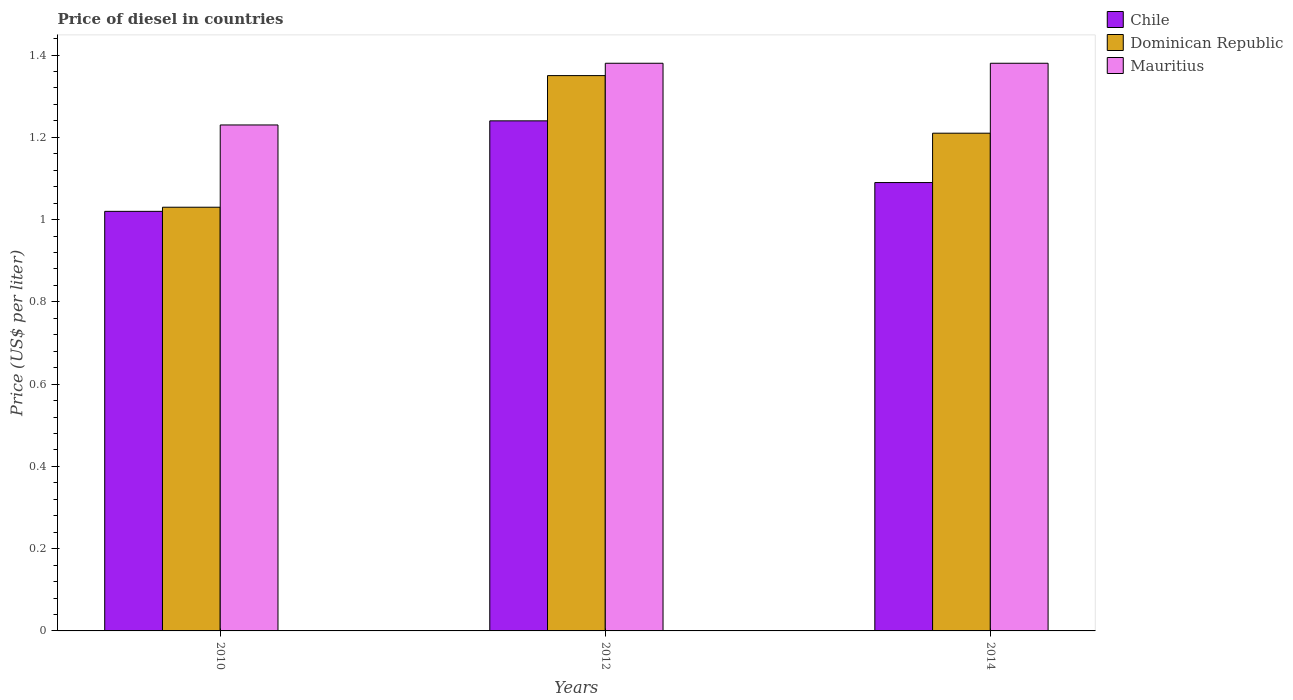How many different coloured bars are there?
Provide a short and direct response. 3. How many bars are there on the 3rd tick from the left?
Offer a terse response. 3. How many bars are there on the 3rd tick from the right?
Provide a succinct answer. 3. What is the label of the 3rd group of bars from the left?
Provide a succinct answer. 2014. What is the price of diesel in Chile in 2012?
Your response must be concise. 1.24. Across all years, what is the maximum price of diesel in Chile?
Keep it short and to the point. 1.24. Across all years, what is the minimum price of diesel in Mauritius?
Keep it short and to the point. 1.23. In which year was the price of diesel in Dominican Republic minimum?
Offer a terse response. 2010. What is the total price of diesel in Mauritius in the graph?
Give a very brief answer. 3.99. What is the difference between the price of diesel in Dominican Republic in 2010 and that in 2012?
Ensure brevity in your answer.  -0.32. What is the difference between the price of diesel in Chile in 2010 and the price of diesel in Dominican Republic in 2014?
Your answer should be very brief. -0.19. What is the average price of diesel in Mauritius per year?
Offer a terse response. 1.33. In the year 2010, what is the difference between the price of diesel in Mauritius and price of diesel in Dominican Republic?
Your answer should be very brief. 0.2. In how many years, is the price of diesel in Mauritius greater than 1.4000000000000001 US$?
Your answer should be very brief. 0. What is the ratio of the price of diesel in Mauritius in 2010 to that in 2012?
Give a very brief answer. 0.89. Is the price of diesel in Chile in 2012 less than that in 2014?
Your response must be concise. No. What is the difference between the highest and the second highest price of diesel in Dominican Republic?
Give a very brief answer. 0.14. What is the difference between the highest and the lowest price of diesel in Chile?
Give a very brief answer. 0.22. In how many years, is the price of diesel in Dominican Republic greater than the average price of diesel in Dominican Republic taken over all years?
Keep it short and to the point. 2. Is the sum of the price of diesel in Chile in 2012 and 2014 greater than the maximum price of diesel in Mauritius across all years?
Make the answer very short. Yes. What does the 3rd bar from the left in 2014 represents?
Provide a succinct answer. Mauritius. What does the 2nd bar from the right in 2012 represents?
Give a very brief answer. Dominican Republic. How many bars are there?
Keep it short and to the point. 9. Are all the bars in the graph horizontal?
Your answer should be very brief. No. Are the values on the major ticks of Y-axis written in scientific E-notation?
Offer a terse response. No. Does the graph contain any zero values?
Your answer should be compact. No. Does the graph contain grids?
Offer a very short reply. No. What is the title of the graph?
Your response must be concise. Price of diesel in countries. What is the label or title of the Y-axis?
Provide a short and direct response. Price (US$ per liter). What is the Price (US$ per liter) of Chile in 2010?
Make the answer very short. 1.02. What is the Price (US$ per liter) of Dominican Republic in 2010?
Keep it short and to the point. 1.03. What is the Price (US$ per liter) in Mauritius in 2010?
Provide a succinct answer. 1.23. What is the Price (US$ per liter) in Chile in 2012?
Your answer should be very brief. 1.24. What is the Price (US$ per liter) in Dominican Republic in 2012?
Provide a short and direct response. 1.35. What is the Price (US$ per liter) in Mauritius in 2012?
Your response must be concise. 1.38. What is the Price (US$ per liter) in Chile in 2014?
Offer a very short reply. 1.09. What is the Price (US$ per liter) in Dominican Republic in 2014?
Provide a short and direct response. 1.21. What is the Price (US$ per liter) of Mauritius in 2014?
Your answer should be very brief. 1.38. Across all years, what is the maximum Price (US$ per liter) of Chile?
Your answer should be compact. 1.24. Across all years, what is the maximum Price (US$ per liter) in Dominican Republic?
Ensure brevity in your answer.  1.35. Across all years, what is the maximum Price (US$ per liter) in Mauritius?
Provide a short and direct response. 1.38. Across all years, what is the minimum Price (US$ per liter) in Dominican Republic?
Make the answer very short. 1.03. Across all years, what is the minimum Price (US$ per liter) in Mauritius?
Ensure brevity in your answer.  1.23. What is the total Price (US$ per liter) in Chile in the graph?
Offer a terse response. 3.35. What is the total Price (US$ per liter) of Dominican Republic in the graph?
Provide a short and direct response. 3.59. What is the total Price (US$ per liter) in Mauritius in the graph?
Provide a short and direct response. 3.99. What is the difference between the Price (US$ per liter) of Chile in 2010 and that in 2012?
Keep it short and to the point. -0.22. What is the difference between the Price (US$ per liter) in Dominican Republic in 2010 and that in 2012?
Provide a short and direct response. -0.32. What is the difference between the Price (US$ per liter) in Chile in 2010 and that in 2014?
Provide a short and direct response. -0.07. What is the difference between the Price (US$ per liter) in Dominican Republic in 2010 and that in 2014?
Your response must be concise. -0.18. What is the difference between the Price (US$ per liter) of Dominican Republic in 2012 and that in 2014?
Keep it short and to the point. 0.14. What is the difference between the Price (US$ per liter) of Mauritius in 2012 and that in 2014?
Keep it short and to the point. 0. What is the difference between the Price (US$ per liter) in Chile in 2010 and the Price (US$ per liter) in Dominican Republic in 2012?
Make the answer very short. -0.33. What is the difference between the Price (US$ per liter) in Chile in 2010 and the Price (US$ per liter) in Mauritius in 2012?
Make the answer very short. -0.36. What is the difference between the Price (US$ per liter) in Dominican Republic in 2010 and the Price (US$ per liter) in Mauritius in 2012?
Provide a short and direct response. -0.35. What is the difference between the Price (US$ per liter) of Chile in 2010 and the Price (US$ per liter) of Dominican Republic in 2014?
Your response must be concise. -0.19. What is the difference between the Price (US$ per liter) of Chile in 2010 and the Price (US$ per liter) of Mauritius in 2014?
Your response must be concise. -0.36. What is the difference between the Price (US$ per liter) in Dominican Republic in 2010 and the Price (US$ per liter) in Mauritius in 2014?
Provide a succinct answer. -0.35. What is the difference between the Price (US$ per liter) of Chile in 2012 and the Price (US$ per liter) of Dominican Republic in 2014?
Provide a succinct answer. 0.03. What is the difference between the Price (US$ per liter) in Chile in 2012 and the Price (US$ per liter) in Mauritius in 2014?
Ensure brevity in your answer.  -0.14. What is the difference between the Price (US$ per liter) in Dominican Republic in 2012 and the Price (US$ per liter) in Mauritius in 2014?
Offer a terse response. -0.03. What is the average Price (US$ per liter) in Chile per year?
Provide a short and direct response. 1.12. What is the average Price (US$ per liter) of Dominican Republic per year?
Keep it short and to the point. 1.2. What is the average Price (US$ per liter) of Mauritius per year?
Provide a succinct answer. 1.33. In the year 2010, what is the difference between the Price (US$ per liter) of Chile and Price (US$ per liter) of Dominican Republic?
Give a very brief answer. -0.01. In the year 2010, what is the difference between the Price (US$ per liter) in Chile and Price (US$ per liter) in Mauritius?
Your response must be concise. -0.21. In the year 2012, what is the difference between the Price (US$ per liter) of Chile and Price (US$ per liter) of Dominican Republic?
Offer a very short reply. -0.11. In the year 2012, what is the difference between the Price (US$ per liter) in Chile and Price (US$ per liter) in Mauritius?
Offer a very short reply. -0.14. In the year 2012, what is the difference between the Price (US$ per liter) of Dominican Republic and Price (US$ per liter) of Mauritius?
Give a very brief answer. -0.03. In the year 2014, what is the difference between the Price (US$ per liter) of Chile and Price (US$ per liter) of Dominican Republic?
Make the answer very short. -0.12. In the year 2014, what is the difference between the Price (US$ per liter) of Chile and Price (US$ per liter) of Mauritius?
Offer a terse response. -0.29. In the year 2014, what is the difference between the Price (US$ per liter) in Dominican Republic and Price (US$ per liter) in Mauritius?
Offer a very short reply. -0.17. What is the ratio of the Price (US$ per liter) in Chile in 2010 to that in 2012?
Your response must be concise. 0.82. What is the ratio of the Price (US$ per liter) of Dominican Republic in 2010 to that in 2012?
Your response must be concise. 0.76. What is the ratio of the Price (US$ per liter) of Mauritius in 2010 to that in 2012?
Ensure brevity in your answer.  0.89. What is the ratio of the Price (US$ per liter) of Chile in 2010 to that in 2014?
Your answer should be compact. 0.94. What is the ratio of the Price (US$ per liter) in Dominican Republic in 2010 to that in 2014?
Give a very brief answer. 0.85. What is the ratio of the Price (US$ per liter) in Mauritius in 2010 to that in 2014?
Provide a succinct answer. 0.89. What is the ratio of the Price (US$ per liter) of Chile in 2012 to that in 2014?
Offer a very short reply. 1.14. What is the ratio of the Price (US$ per liter) in Dominican Republic in 2012 to that in 2014?
Keep it short and to the point. 1.12. What is the ratio of the Price (US$ per liter) of Mauritius in 2012 to that in 2014?
Keep it short and to the point. 1. What is the difference between the highest and the second highest Price (US$ per liter) of Chile?
Your answer should be very brief. 0.15. What is the difference between the highest and the second highest Price (US$ per liter) of Dominican Republic?
Your response must be concise. 0.14. What is the difference between the highest and the second highest Price (US$ per liter) in Mauritius?
Offer a very short reply. 0. What is the difference between the highest and the lowest Price (US$ per liter) in Chile?
Provide a short and direct response. 0.22. What is the difference between the highest and the lowest Price (US$ per liter) in Dominican Republic?
Offer a very short reply. 0.32. What is the difference between the highest and the lowest Price (US$ per liter) of Mauritius?
Offer a terse response. 0.15. 